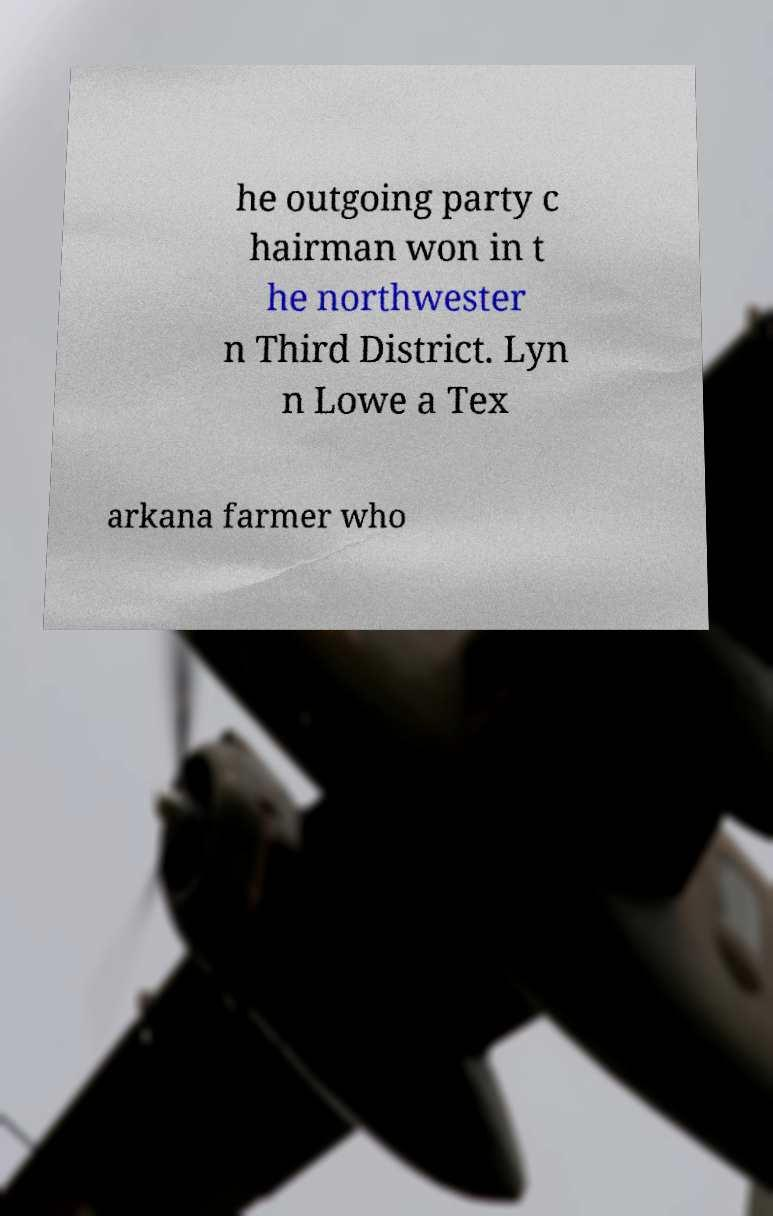Can you read and provide the text displayed in the image?This photo seems to have some interesting text. Can you extract and type it out for me? he outgoing party c hairman won in t he northwester n Third District. Lyn n Lowe a Tex arkana farmer who 